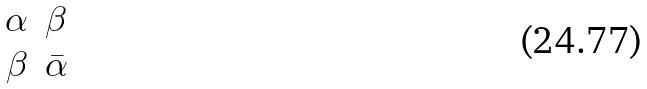Convert formula to latex. <formula><loc_0><loc_0><loc_500><loc_500>\begin{matrix} \alpha & \beta \\ \beta & \bar { \alpha } \end{matrix}</formula> 